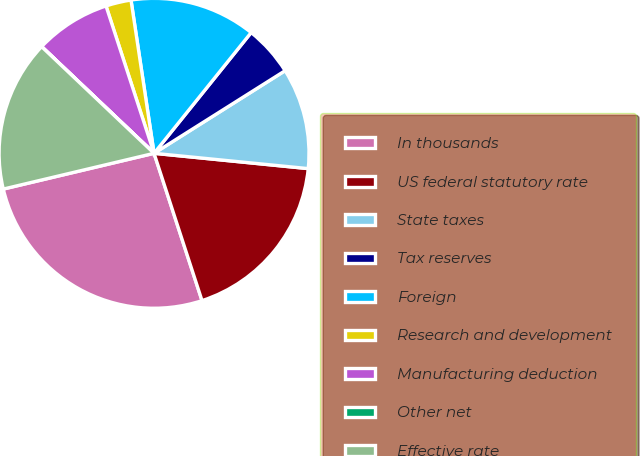Convert chart to OTSL. <chart><loc_0><loc_0><loc_500><loc_500><pie_chart><fcel>In thousands<fcel>US federal statutory rate<fcel>State taxes<fcel>Tax reserves<fcel>Foreign<fcel>Research and development<fcel>Manufacturing deduction<fcel>Other net<fcel>Effective rate<nl><fcel>26.31%<fcel>18.42%<fcel>10.53%<fcel>5.27%<fcel>13.16%<fcel>2.64%<fcel>7.9%<fcel>0.01%<fcel>15.79%<nl></chart> 